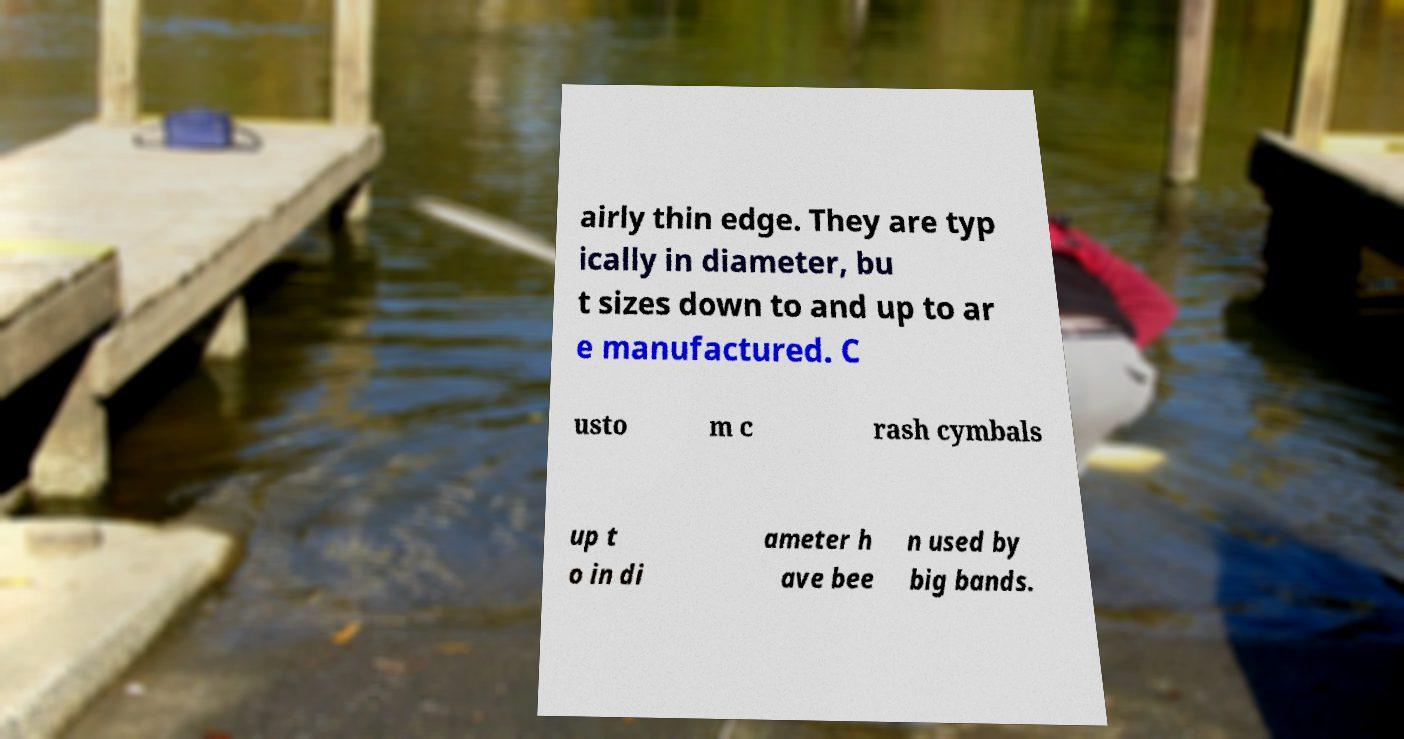Can you accurately transcribe the text from the provided image for me? airly thin edge. They are typ ically in diameter, bu t sizes down to and up to ar e manufactured. C usto m c rash cymbals up t o in di ameter h ave bee n used by big bands. 